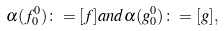<formula> <loc_0><loc_0><loc_500><loc_500>\alpha ( f ^ { 0 } _ { 0 } ) \colon = [ f ] a n d \alpha ( g ^ { 0 } _ { 0 } ) \colon = [ g ] ,</formula> 